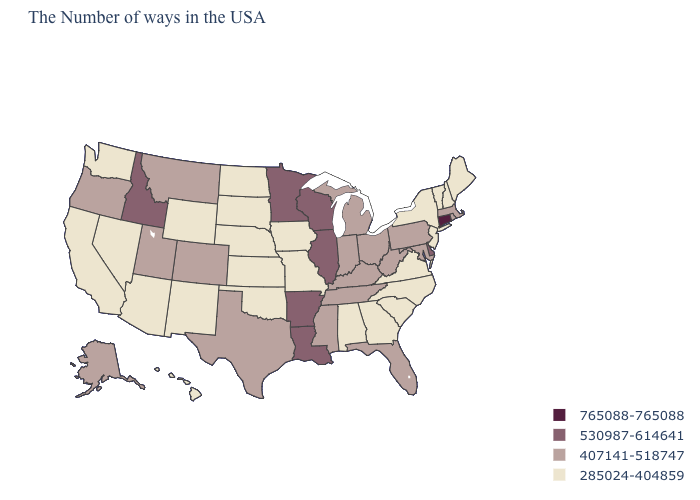Name the states that have a value in the range 530987-614641?
Keep it brief. Delaware, Wisconsin, Illinois, Louisiana, Arkansas, Minnesota, Idaho. Among the states that border Oklahoma , which have the lowest value?
Answer briefly. Missouri, Kansas, New Mexico. What is the value of North Dakota?
Quick response, please. 285024-404859. Name the states that have a value in the range 530987-614641?
Give a very brief answer. Delaware, Wisconsin, Illinois, Louisiana, Arkansas, Minnesota, Idaho. Among the states that border Missouri , does Kansas have the lowest value?
Answer briefly. Yes. Does Rhode Island have a lower value than Idaho?
Concise answer only. Yes. Among the states that border Massachusetts , does New York have the highest value?
Quick response, please. No. Which states have the highest value in the USA?
Answer briefly. Connecticut. Among the states that border Indiana , does Kentucky have the highest value?
Concise answer only. No. Among the states that border Maryland , which have the highest value?
Give a very brief answer. Delaware. What is the lowest value in states that border Maine?
Concise answer only. 285024-404859. What is the value of Tennessee?
Give a very brief answer. 407141-518747. What is the value of Utah?
Keep it brief. 407141-518747. Name the states that have a value in the range 530987-614641?
Answer briefly. Delaware, Wisconsin, Illinois, Louisiana, Arkansas, Minnesota, Idaho. Which states have the lowest value in the Northeast?
Be succinct. Maine, New Hampshire, Vermont, New York, New Jersey. 